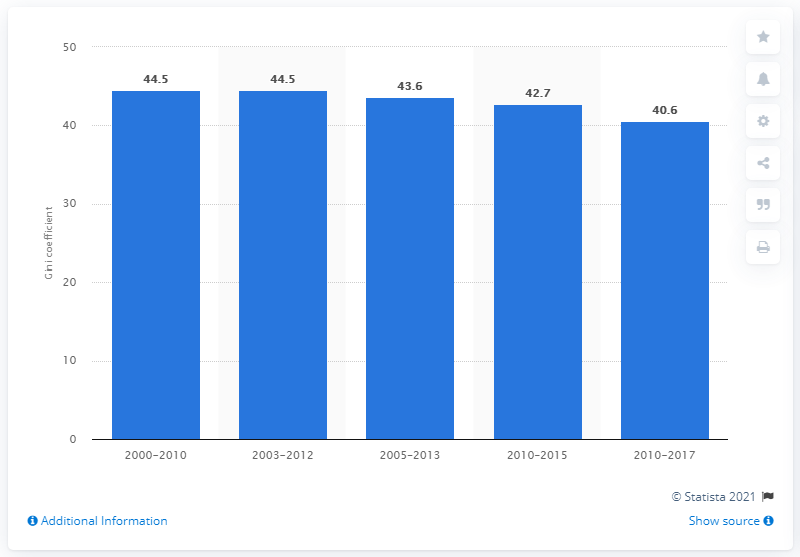Indicate a few pertinent items in this graphic. In 2012, Argentina's Gini coefficient was 44.5, according to data available. 